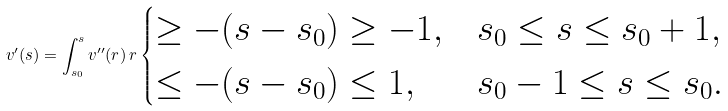Convert formula to latex. <formula><loc_0><loc_0><loc_500><loc_500>v ^ { \prime } ( s ) = \int _ { s _ { 0 } } ^ { s } v ^ { \prime \prime } ( r ) \, r \begin{cases} \geq - ( s - s _ { 0 } ) \geq - 1 , & s _ { 0 } \leq s \leq s _ { 0 } + 1 , \\ \leq - ( s - s _ { 0 } ) \leq 1 , & s _ { 0 } - 1 \leq s \leq s _ { 0 } . \end{cases}</formula> 